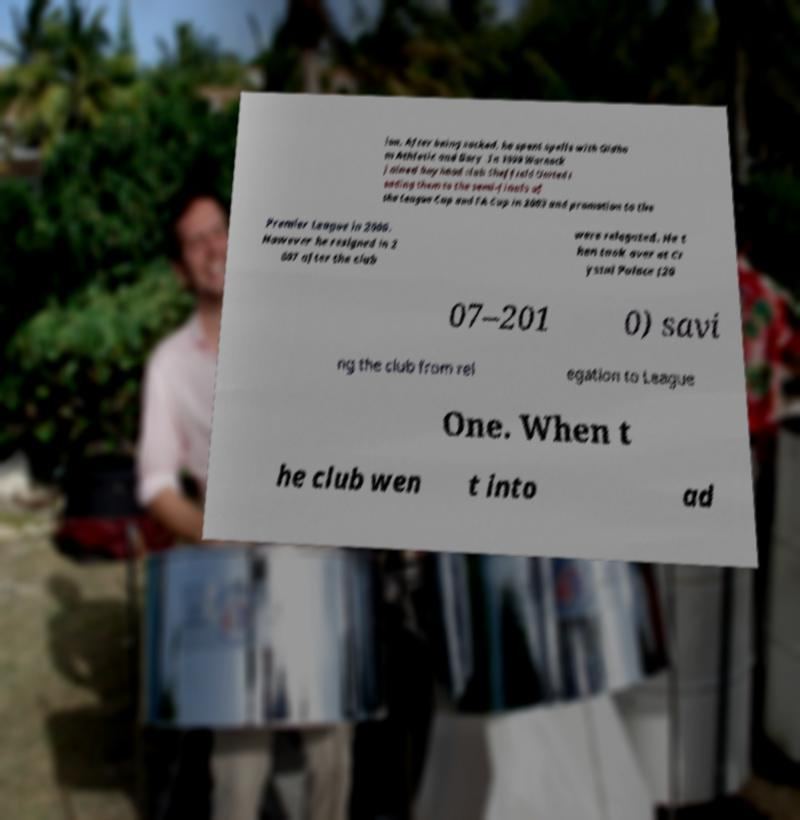What messages or text are displayed in this image? I need them in a readable, typed format. ion. After being sacked, he spent spells with Oldha m Athletic and Bury .In 1999 Warnock joined boyhood club Sheffield United l eading them to the semi-finals of the League Cup and FA Cup in 2003 and promotion to the Premier League in 2006. However he resigned in 2 007 after the club were relegated. He t hen took over at Cr ystal Palace (20 07–201 0) savi ng the club from rel egation to League One. When t he club wen t into ad 